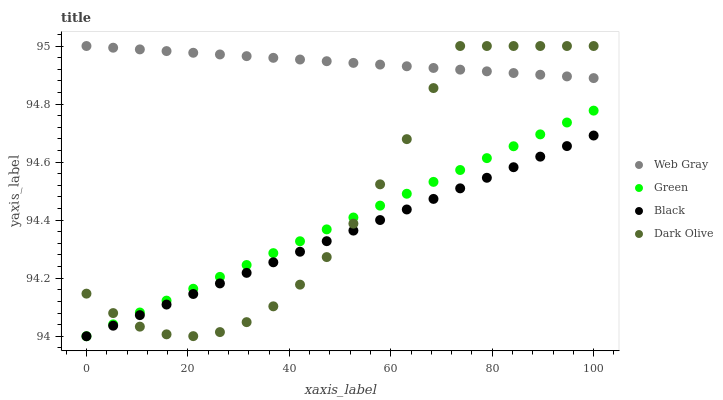Does Black have the minimum area under the curve?
Answer yes or no. Yes. Does Web Gray have the maximum area under the curve?
Answer yes or no. Yes. Does Web Gray have the minimum area under the curve?
Answer yes or no. No. Does Black have the maximum area under the curve?
Answer yes or no. No. Is Web Gray the smoothest?
Answer yes or no. Yes. Is Dark Olive the roughest?
Answer yes or no. Yes. Is Black the smoothest?
Answer yes or no. No. Is Black the roughest?
Answer yes or no. No. Does Black have the lowest value?
Answer yes or no. Yes. Does Web Gray have the lowest value?
Answer yes or no. No. Does Web Gray have the highest value?
Answer yes or no. Yes. Does Black have the highest value?
Answer yes or no. No. Is Black less than Web Gray?
Answer yes or no. Yes. Is Web Gray greater than Black?
Answer yes or no. Yes. Does Black intersect Green?
Answer yes or no. Yes. Is Black less than Green?
Answer yes or no. No. Is Black greater than Green?
Answer yes or no. No. Does Black intersect Web Gray?
Answer yes or no. No. 